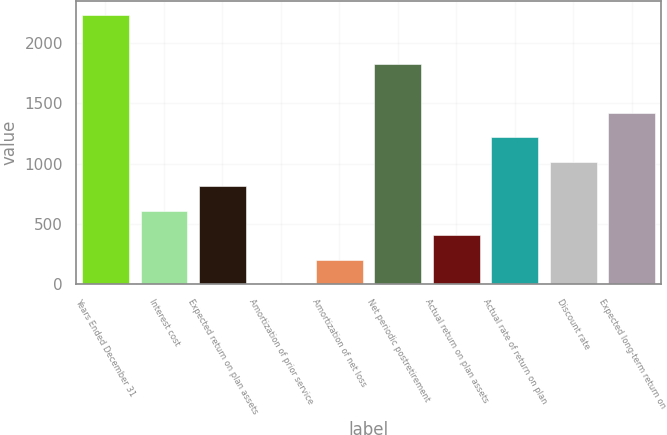<chart> <loc_0><loc_0><loc_500><loc_500><bar_chart><fcel>Years Ended December 31<fcel>Interest cost<fcel>Expected return on plan assets<fcel>Amortization of prior service<fcel>Amortization of net loss<fcel>Net periodic postretirement<fcel>Actual return on plan assets<fcel>Actual rate of return on plan<fcel>Discount rate<fcel>Expected long-term return on<nl><fcel>2234<fcel>610<fcel>813<fcel>1<fcel>204<fcel>1828<fcel>407<fcel>1219<fcel>1016<fcel>1422<nl></chart> 